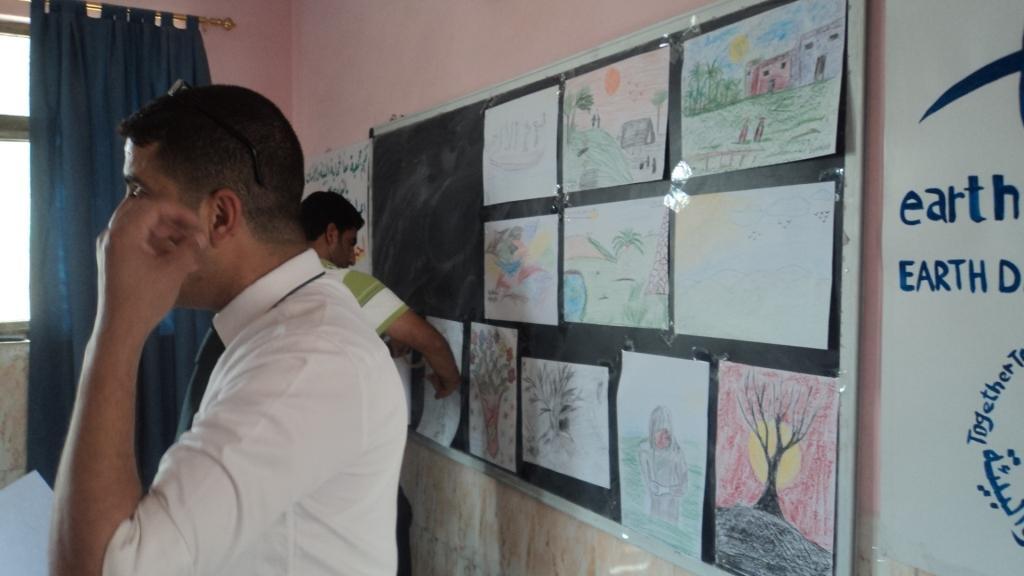Could you give a brief overview of what you see in this image? This is the picture of a room. In this image there are two persons standing. On the right side of there is a board and there are posters on the wall. At the back there is a curtain and there is a window. 